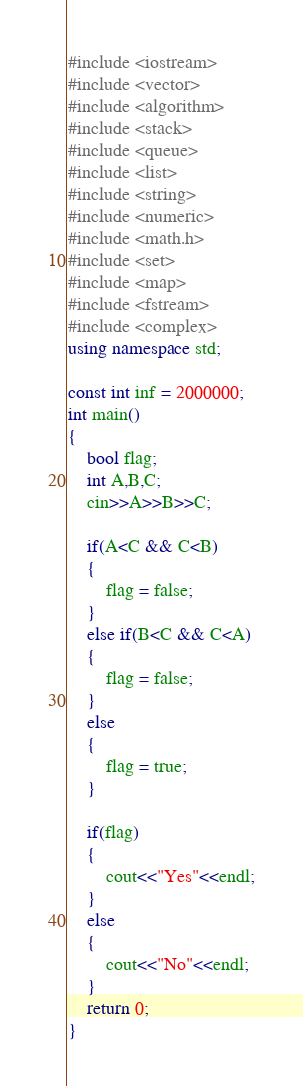Convert code to text. <code><loc_0><loc_0><loc_500><loc_500><_C++_>#include <iostream>
#include <vector>
#include <algorithm>
#include <stack>
#include <queue>
#include <list>
#include <string>
#include <numeric>
#include <math.h>
#include <set>
#include <map>
#include <fstream>
#include <complex>
using namespace std;

const int inf = 2000000;
int main()
{
	bool flag;
	int A,B,C;
	cin>>A>>B>>C;

	if(A<C && C<B)
	{
		flag = false;
	}
	else if(B<C && C<A)
	{
		flag = false;
	}
	else
	{
		flag = true;
	}

	if(flag)
	{
		cout<<"Yes"<<endl;
	}
	else
	{
		cout<<"No"<<endl;
	}
	return 0;
}</code> 